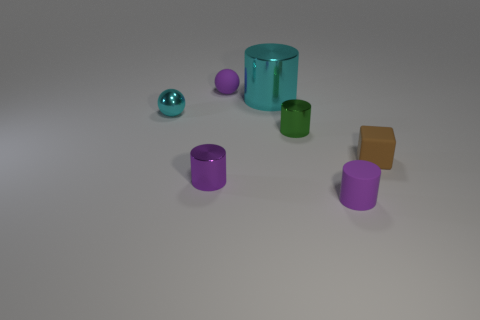What number of tiny objects are the same shape as the big cyan object?
Offer a very short reply. 3. What number of big blue matte things are there?
Ensure brevity in your answer.  0. What is the color of the small cylinder that is behind the tiny purple shiny cylinder?
Make the answer very short. Green. There is a matte object that is in front of the purple cylinder to the left of the green object; what is its color?
Your answer should be very brief. Purple. The block that is the same size as the green metal thing is what color?
Your response must be concise. Brown. How many things are both on the left side of the purple rubber cylinder and behind the tiny purple metal cylinder?
Your answer should be very brief. 4. What is the shape of the big shiny thing that is the same color as the small metallic sphere?
Your answer should be compact. Cylinder. What material is the thing that is both left of the small purple sphere and to the right of the tiny cyan object?
Make the answer very short. Metal. Is the number of small purple shiny cylinders behind the purple matte ball less than the number of large cyan metal cylinders on the left side of the small brown matte object?
Ensure brevity in your answer.  Yes. What is the size of the purple thing that is made of the same material as the green thing?
Keep it short and to the point. Small. 